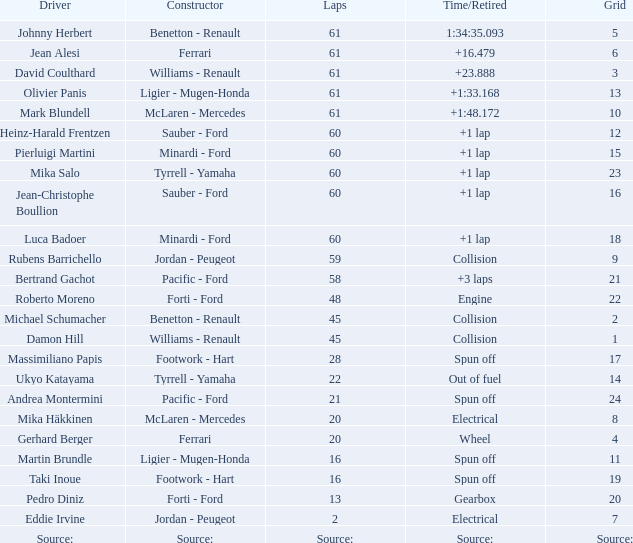How many laps has luca badoer finished? 60.0. 